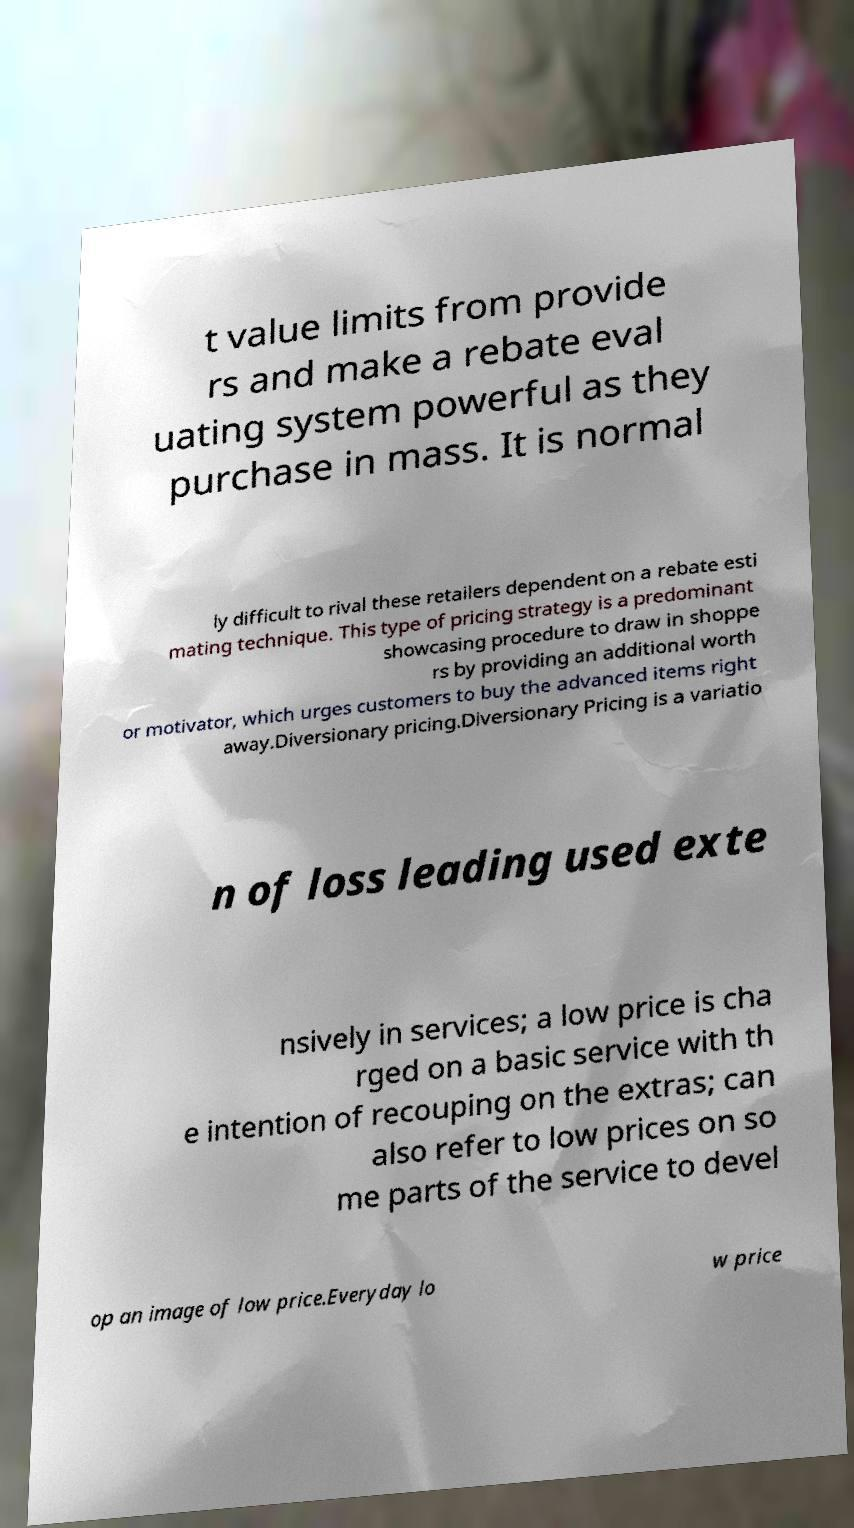Can you read and provide the text displayed in the image?This photo seems to have some interesting text. Can you extract and type it out for me? t value limits from provide rs and make a rebate eval uating system powerful as they purchase in mass. It is normal ly difficult to rival these retailers dependent on a rebate esti mating technique. This type of pricing strategy is a predominant showcasing procedure to draw in shoppe rs by providing an additional worth or motivator, which urges customers to buy the advanced items right away.Diversionary pricing.Diversionary Pricing is a variatio n of loss leading used exte nsively in services; a low price is cha rged on a basic service with th e intention of recouping on the extras; can also refer to low prices on so me parts of the service to devel op an image of low price.Everyday lo w price 